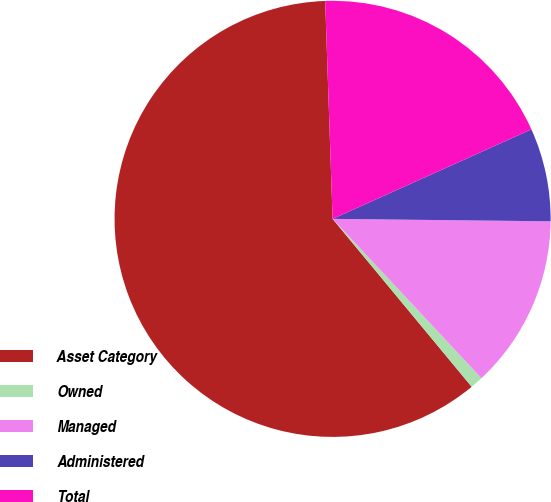Convert chart. <chart><loc_0><loc_0><loc_500><loc_500><pie_chart><fcel>Asset Category<fcel>Owned<fcel>Managed<fcel>Administered<fcel>Total<nl><fcel>60.47%<fcel>0.95%<fcel>12.86%<fcel>6.91%<fcel>18.81%<nl></chart> 